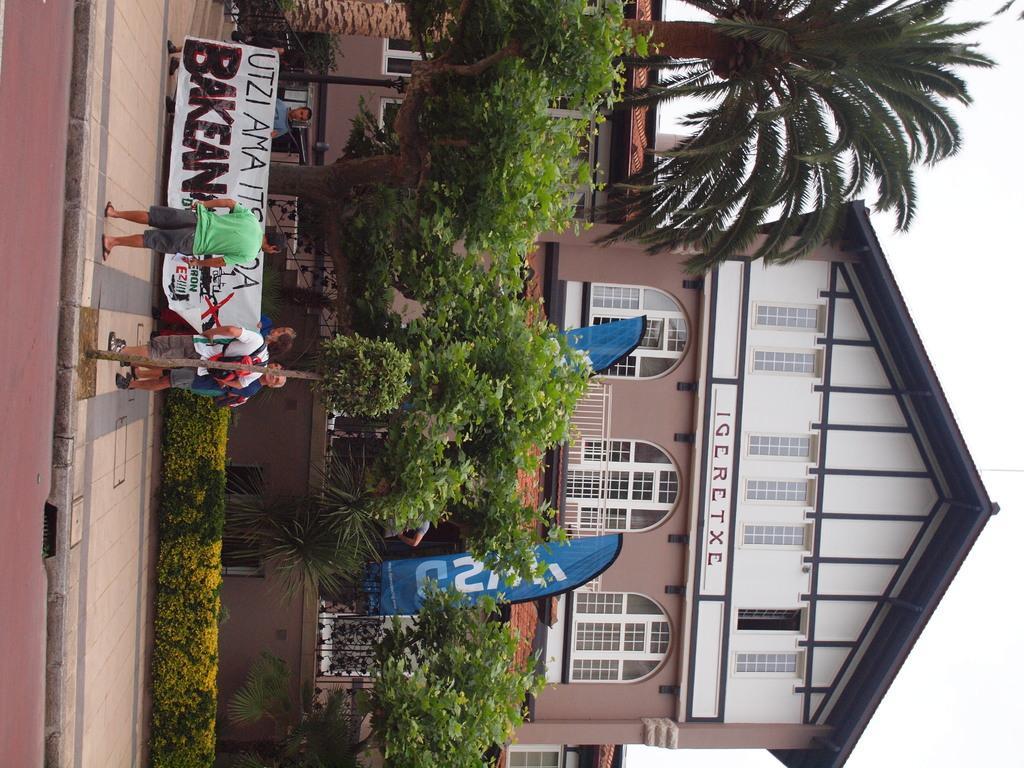In one or two sentences, can you explain what this image depicts? In this image, we can see some houses, people, trees, plants, a pole. We can also see some posters with text. We can see the ground and the sky. 